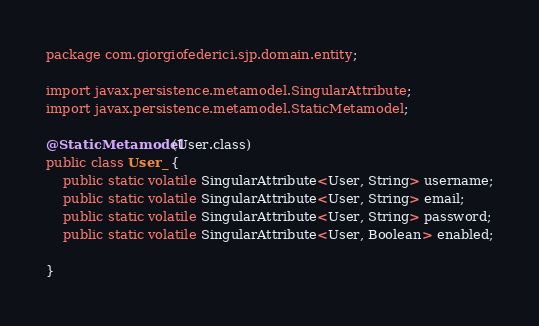<code> <loc_0><loc_0><loc_500><loc_500><_Java_>package com.giorgiofederici.sjp.domain.entity;

import javax.persistence.metamodel.SingularAttribute;
import javax.persistence.metamodel.StaticMetamodel;

@StaticMetamodel(User.class)
public class User_ {
	public static volatile SingularAttribute<User, String> username;
	public static volatile SingularAttribute<User, String> email;
	public static volatile SingularAttribute<User, String> password;
	public static volatile SingularAttribute<User, Boolean> enabled;

}
</code> 